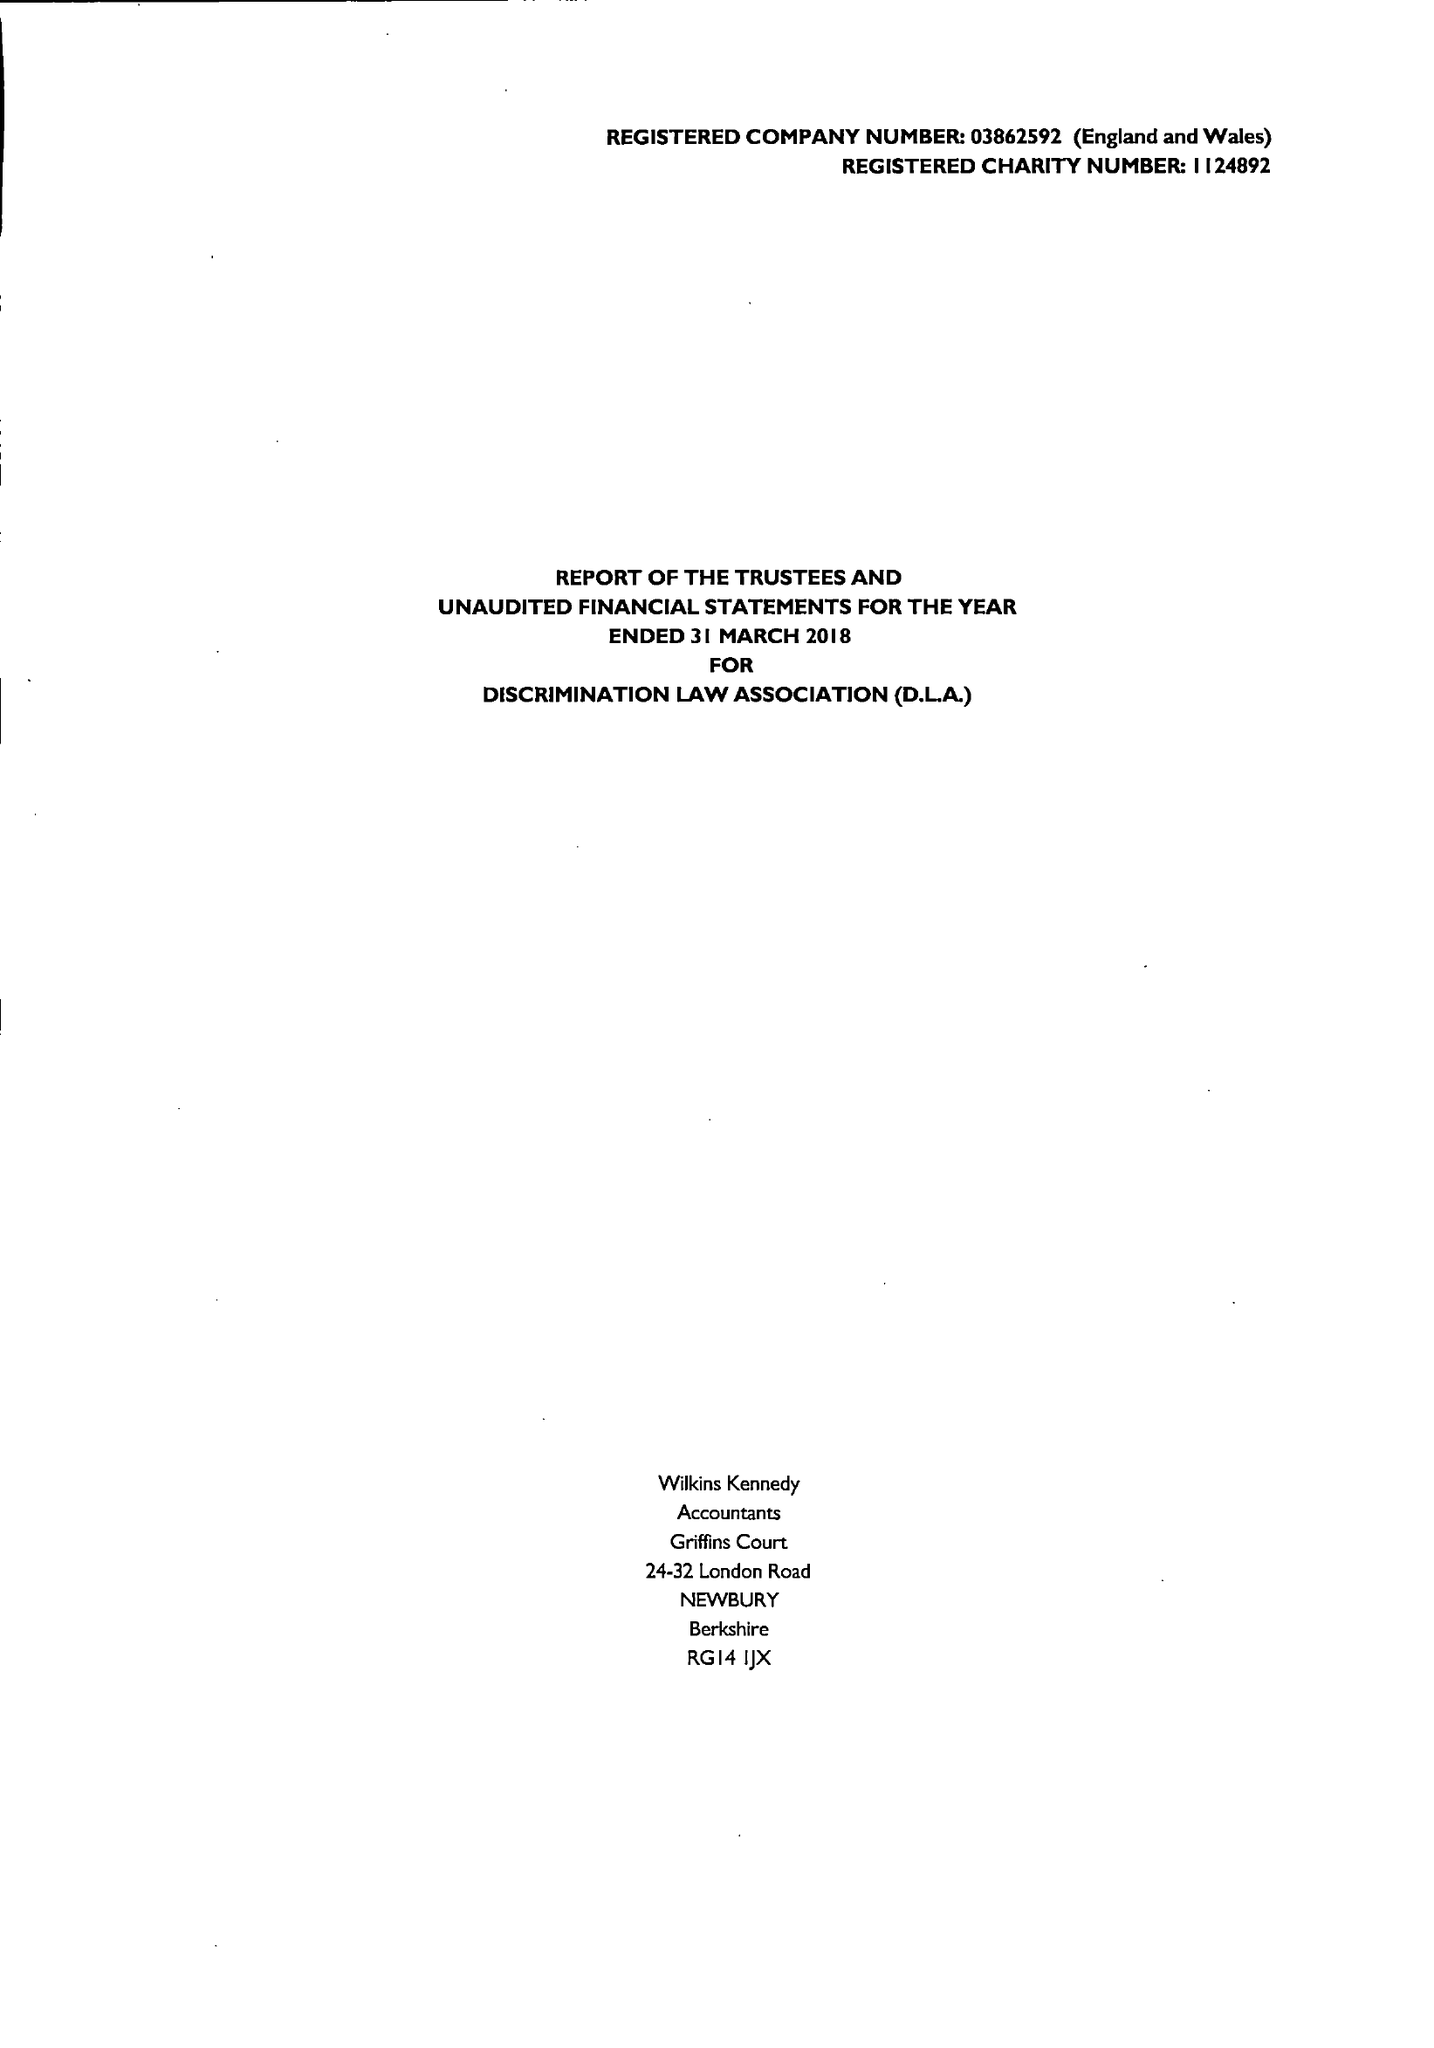What is the value for the address__post_town?
Answer the question using a single word or phrase. LONDON 